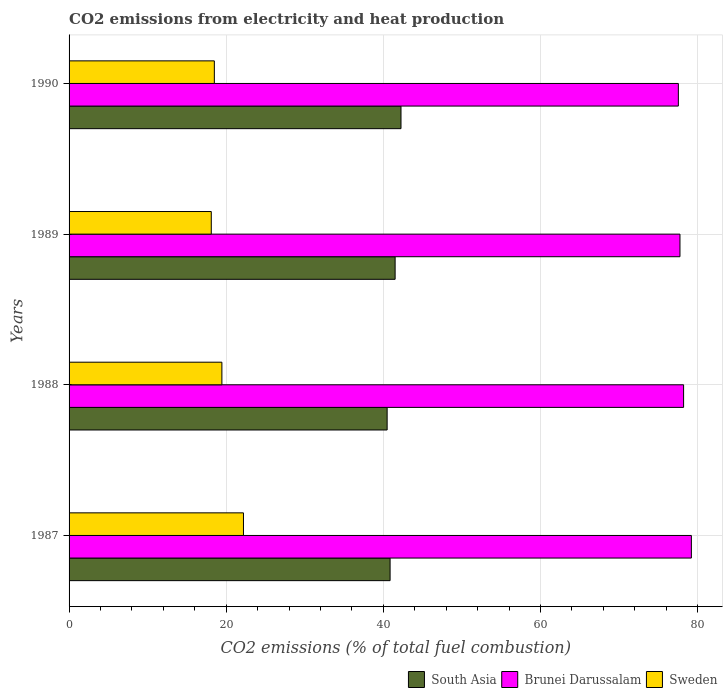How many bars are there on the 3rd tick from the top?
Make the answer very short. 3. What is the amount of CO2 emitted in Brunei Darussalam in 1989?
Your answer should be very brief. 77.74. Across all years, what is the maximum amount of CO2 emitted in Sweden?
Provide a short and direct response. 22.19. Across all years, what is the minimum amount of CO2 emitted in Brunei Darussalam?
Ensure brevity in your answer.  77.54. In which year was the amount of CO2 emitted in South Asia maximum?
Keep it short and to the point. 1990. In which year was the amount of CO2 emitted in Brunei Darussalam minimum?
Provide a succinct answer. 1990. What is the total amount of CO2 emitted in Brunei Darussalam in the graph?
Offer a terse response. 312.68. What is the difference between the amount of CO2 emitted in Brunei Darussalam in 1987 and that in 1990?
Give a very brief answer. 1.66. What is the difference between the amount of CO2 emitted in Sweden in 1988 and the amount of CO2 emitted in Brunei Darussalam in 1989?
Make the answer very short. -58.29. What is the average amount of CO2 emitted in South Asia per year?
Offer a very short reply. 41.27. In the year 1989, what is the difference between the amount of CO2 emitted in South Asia and amount of CO2 emitted in Sweden?
Provide a short and direct response. 23.39. What is the ratio of the amount of CO2 emitted in Brunei Darussalam in 1987 to that in 1989?
Your response must be concise. 1.02. What is the difference between the highest and the second highest amount of CO2 emitted in Sweden?
Provide a succinct answer. 2.75. What is the difference between the highest and the lowest amount of CO2 emitted in Brunei Darussalam?
Provide a short and direct response. 1.66. In how many years, is the amount of CO2 emitted in Brunei Darussalam greater than the average amount of CO2 emitted in Brunei Darussalam taken over all years?
Your answer should be compact. 2. What does the 3rd bar from the bottom in 1987 represents?
Your answer should be very brief. Sweden. What is the title of the graph?
Provide a succinct answer. CO2 emissions from electricity and heat production. What is the label or title of the X-axis?
Offer a terse response. CO2 emissions (% of total fuel combustion). What is the label or title of the Y-axis?
Keep it short and to the point. Years. What is the CO2 emissions (% of total fuel combustion) in South Asia in 1987?
Provide a succinct answer. 40.85. What is the CO2 emissions (% of total fuel combustion) in Brunei Darussalam in 1987?
Make the answer very short. 79.19. What is the CO2 emissions (% of total fuel combustion) in Sweden in 1987?
Your answer should be very brief. 22.19. What is the CO2 emissions (% of total fuel combustion) of South Asia in 1988?
Your response must be concise. 40.48. What is the CO2 emissions (% of total fuel combustion) of Brunei Darussalam in 1988?
Keep it short and to the point. 78.21. What is the CO2 emissions (% of total fuel combustion) in Sweden in 1988?
Provide a succinct answer. 19.45. What is the CO2 emissions (% of total fuel combustion) in South Asia in 1989?
Give a very brief answer. 41.49. What is the CO2 emissions (% of total fuel combustion) of Brunei Darussalam in 1989?
Ensure brevity in your answer.  77.74. What is the CO2 emissions (% of total fuel combustion) of Sweden in 1989?
Your answer should be compact. 18.1. What is the CO2 emissions (% of total fuel combustion) of South Asia in 1990?
Give a very brief answer. 42.24. What is the CO2 emissions (% of total fuel combustion) in Brunei Darussalam in 1990?
Your response must be concise. 77.54. What is the CO2 emissions (% of total fuel combustion) of Sweden in 1990?
Give a very brief answer. 18.49. Across all years, what is the maximum CO2 emissions (% of total fuel combustion) of South Asia?
Your answer should be compact. 42.24. Across all years, what is the maximum CO2 emissions (% of total fuel combustion) of Brunei Darussalam?
Make the answer very short. 79.19. Across all years, what is the maximum CO2 emissions (% of total fuel combustion) in Sweden?
Keep it short and to the point. 22.19. Across all years, what is the minimum CO2 emissions (% of total fuel combustion) in South Asia?
Your answer should be compact. 40.48. Across all years, what is the minimum CO2 emissions (% of total fuel combustion) in Brunei Darussalam?
Your response must be concise. 77.54. Across all years, what is the minimum CO2 emissions (% of total fuel combustion) in Sweden?
Your response must be concise. 18.1. What is the total CO2 emissions (% of total fuel combustion) in South Asia in the graph?
Your answer should be very brief. 165.06. What is the total CO2 emissions (% of total fuel combustion) in Brunei Darussalam in the graph?
Your answer should be very brief. 312.68. What is the total CO2 emissions (% of total fuel combustion) of Sweden in the graph?
Give a very brief answer. 78.23. What is the difference between the CO2 emissions (% of total fuel combustion) of South Asia in 1987 and that in 1988?
Your response must be concise. 0.38. What is the difference between the CO2 emissions (% of total fuel combustion) of Sweden in 1987 and that in 1988?
Provide a short and direct response. 2.75. What is the difference between the CO2 emissions (% of total fuel combustion) in South Asia in 1987 and that in 1989?
Give a very brief answer. -0.64. What is the difference between the CO2 emissions (% of total fuel combustion) of Brunei Darussalam in 1987 and that in 1989?
Make the answer very short. 1.45. What is the difference between the CO2 emissions (% of total fuel combustion) in Sweden in 1987 and that in 1989?
Keep it short and to the point. 4.1. What is the difference between the CO2 emissions (% of total fuel combustion) of South Asia in 1987 and that in 1990?
Give a very brief answer. -1.39. What is the difference between the CO2 emissions (% of total fuel combustion) in Brunei Darussalam in 1987 and that in 1990?
Make the answer very short. 1.66. What is the difference between the CO2 emissions (% of total fuel combustion) of Sweden in 1987 and that in 1990?
Provide a short and direct response. 3.71. What is the difference between the CO2 emissions (% of total fuel combustion) of South Asia in 1988 and that in 1989?
Your response must be concise. -1.02. What is the difference between the CO2 emissions (% of total fuel combustion) in Brunei Darussalam in 1988 and that in 1989?
Provide a short and direct response. 0.46. What is the difference between the CO2 emissions (% of total fuel combustion) in Sweden in 1988 and that in 1989?
Ensure brevity in your answer.  1.35. What is the difference between the CO2 emissions (% of total fuel combustion) of South Asia in 1988 and that in 1990?
Your answer should be compact. -1.76. What is the difference between the CO2 emissions (% of total fuel combustion) of Brunei Darussalam in 1988 and that in 1990?
Your answer should be very brief. 0.67. What is the difference between the CO2 emissions (% of total fuel combustion) in Sweden in 1988 and that in 1990?
Ensure brevity in your answer.  0.96. What is the difference between the CO2 emissions (% of total fuel combustion) in South Asia in 1989 and that in 1990?
Offer a terse response. -0.75. What is the difference between the CO2 emissions (% of total fuel combustion) of Brunei Darussalam in 1989 and that in 1990?
Offer a very short reply. 0.2. What is the difference between the CO2 emissions (% of total fuel combustion) in Sweden in 1989 and that in 1990?
Your answer should be very brief. -0.39. What is the difference between the CO2 emissions (% of total fuel combustion) of South Asia in 1987 and the CO2 emissions (% of total fuel combustion) of Brunei Darussalam in 1988?
Your answer should be compact. -37.35. What is the difference between the CO2 emissions (% of total fuel combustion) in South Asia in 1987 and the CO2 emissions (% of total fuel combustion) in Sweden in 1988?
Give a very brief answer. 21.4. What is the difference between the CO2 emissions (% of total fuel combustion) of Brunei Darussalam in 1987 and the CO2 emissions (% of total fuel combustion) of Sweden in 1988?
Offer a terse response. 59.75. What is the difference between the CO2 emissions (% of total fuel combustion) of South Asia in 1987 and the CO2 emissions (% of total fuel combustion) of Brunei Darussalam in 1989?
Offer a terse response. -36.89. What is the difference between the CO2 emissions (% of total fuel combustion) of South Asia in 1987 and the CO2 emissions (% of total fuel combustion) of Sweden in 1989?
Your answer should be very brief. 22.75. What is the difference between the CO2 emissions (% of total fuel combustion) of Brunei Darussalam in 1987 and the CO2 emissions (% of total fuel combustion) of Sweden in 1989?
Your answer should be very brief. 61.1. What is the difference between the CO2 emissions (% of total fuel combustion) in South Asia in 1987 and the CO2 emissions (% of total fuel combustion) in Brunei Darussalam in 1990?
Ensure brevity in your answer.  -36.69. What is the difference between the CO2 emissions (% of total fuel combustion) in South Asia in 1987 and the CO2 emissions (% of total fuel combustion) in Sweden in 1990?
Offer a very short reply. 22.36. What is the difference between the CO2 emissions (% of total fuel combustion) of Brunei Darussalam in 1987 and the CO2 emissions (% of total fuel combustion) of Sweden in 1990?
Offer a terse response. 60.71. What is the difference between the CO2 emissions (% of total fuel combustion) in South Asia in 1988 and the CO2 emissions (% of total fuel combustion) in Brunei Darussalam in 1989?
Provide a succinct answer. -37.27. What is the difference between the CO2 emissions (% of total fuel combustion) in South Asia in 1988 and the CO2 emissions (% of total fuel combustion) in Sweden in 1989?
Make the answer very short. 22.38. What is the difference between the CO2 emissions (% of total fuel combustion) in Brunei Darussalam in 1988 and the CO2 emissions (% of total fuel combustion) in Sweden in 1989?
Provide a short and direct response. 60.11. What is the difference between the CO2 emissions (% of total fuel combustion) in South Asia in 1988 and the CO2 emissions (% of total fuel combustion) in Brunei Darussalam in 1990?
Make the answer very short. -37.06. What is the difference between the CO2 emissions (% of total fuel combustion) of South Asia in 1988 and the CO2 emissions (% of total fuel combustion) of Sweden in 1990?
Offer a terse response. 21.99. What is the difference between the CO2 emissions (% of total fuel combustion) of Brunei Darussalam in 1988 and the CO2 emissions (% of total fuel combustion) of Sweden in 1990?
Give a very brief answer. 59.72. What is the difference between the CO2 emissions (% of total fuel combustion) of South Asia in 1989 and the CO2 emissions (% of total fuel combustion) of Brunei Darussalam in 1990?
Offer a terse response. -36.05. What is the difference between the CO2 emissions (% of total fuel combustion) in South Asia in 1989 and the CO2 emissions (% of total fuel combustion) in Sweden in 1990?
Ensure brevity in your answer.  23. What is the difference between the CO2 emissions (% of total fuel combustion) of Brunei Darussalam in 1989 and the CO2 emissions (% of total fuel combustion) of Sweden in 1990?
Offer a very short reply. 59.25. What is the average CO2 emissions (% of total fuel combustion) in South Asia per year?
Keep it short and to the point. 41.27. What is the average CO2 emissions (% of total fuel combustion) of Brunei Darussalam per year?
Keep it short and to the point. 78.17. What is the average CO2 emissions (% of total fuel combustion) in Sweden per year?
Provide a succinct answer. 19.56. In the year 1987, what is the difference between the CO2 emissions (% of total fuel combustion) in South Asia and CO2 emissions (% of total fuel combustion) in Brunei Darussalam?
Give a very brief answer. -38.34. In the year 1987, what is the difference between the CO2 emissions (% of total fuel combustion) of South Asia and CO2 emissions (% of total fuel combustion) of Sweden?
Your answer should be very brief. 18.66. In the year 1987, what is the difference between the CO2 emissions (% of total fuel combustion) in Brunei Darussalam and CO2 emissions (% of total fuel combustion) in Sweden?
Your answer should be compact. 57. In the year 1988, what is the difference between the CO2 emissions (% of total fuel combustion) of South Asia and CO2 emissions (% of total fuel combustion) of Brunei Darussalam?
Offer a terse response. -37.73. In the year 1988, what is the difference between the CO2 emissions (% of total fuel combustion) of South Asia and CO2 emissions (% of total fuel combustion) of Sweden?
Provide a succinct answer. 21.03. In the year 1988, what is the difference between the CO2 emissions (% of total fuel combustion) of Brunei Darussalam and CO2 emissions (% of total fuel combustion) of Sweden?
Your answer should be very brief. 58.76. In the year 1989, what is the difference between the CO2 emissions (% of total fuel combustion) of South Asia and CO2 emissions (% of total fuel combustion) of Brunei Darussalam?
Make the answer very short. -36.25. In the year 1989, what is the difference between the CO2 emissions (% of total fuel combustion) in South Asia and CO2 emissions (% of total fuel combustion) in Sweden?
Provide a succinct answer. 23.39. In the year 1989, what is the difference between the CO2 emissions (% of total fuel combustion) of Brunei Darussalam and CO2 emissions (% of total fuel combustion) of Sweden?
Make the answer very short. 59.64. In the year 1990, what is the difference between the CO2 emissions (% of total fuel combustion) of South Asia and CO2 emissions (% of total fuel combustion) of Brunei Darussalam?
Your answer should be very brief. -35.3. In the year 1990, what is the difference between the CO2 emissions (% of total fuel combustion) of South Asia and CO2 emissions (% of total fuel combustion) of Sweden?
Your answer should be very brief. 23.75. In the year 1990, what is the difference between the CO2 emissions (% of total fuel combustion) in Brunei Darussalam and CO2 emissions (% of total fuel combustion) in Sweden?
Ensure brevity in your answer.  59.05. What is the ratio of the CO2 emissions (% of total fuel combustion) of South Asia in 1987 to that in 1988?
Make the answer very short. 1.01. What is the ratio of the CO2 emissions (% of total fuel combustion) in Brunei Darussalam in 1987 to that in 1988?
Ensure brevity in your answer.  1.01. What is the ratio of the CO2 emissions (% of total fuel combustion) in Sweden in 1987 to that in 1988?
Make the answer very short. 1.14. What is the ratio of the CO2 emissions (% of total fuel combustion) in South Asia in 1987 to that in 1989?
Offer a very short reply. 0.98. What is the ratio of the CO2 emissions (% of total fuel combustion) of Brunei Darussalam in 1987 to that in 1989?
Offer a very short reply. 1.02. What is the ratio of the CO2 emissions (% of total fuel combustion) of Sweden in 1987 to that in 1989?
Your answer should be very brief. 1.23. What is the ratio of the CO2 emissions (% of total fuel combustion) in South Asia in 1987 to that in 1990?
Your response must be concise. 0.97. What is the ratio of the CO2 emissions (% of total fuel combustion) of Brunei Darussalam in 1987 to that in 1990?
Make the answer very short. 1.02. What is the ratio of the CO2 emissions (% of total fuel combustion) of Sweden in 1987 to that in 1990?
Offer a very short reply. 1.2. What is the ratio of the CO2 emissions (% of total fuel combustion) of South Asia in 1988 to that in 1989?
Provide a succinct answer. 0.98. What is the ratio of the CO2 emissions (% of total fuel combustion) of Sweden in 1988 to that in 1989?
Your answer should be compact. 1.07. What is the ratio of the CO2 emissions (% of total fuel combustion) of South Asia in 1988 to that in 1990?
Offer a very short reply. 0.96. What is the ratio of the CO2 emissions (% of total fuel combustion) in Brunei Darussalam in 1988 to that in 1990?
Your answer should be very brief. 1.01. What is the ratio of the CO2 emissions (% of total fuel combustion) in Sweden in 1988 to that in 1990?
Offer a very short reply. 1.05. What is the ratio of the CO2 emissions (% of total fuel combustion) in South Asia in 1989 to that in 1990?
Make the answer very short. 0.98. What is the ratio of the CO2 emissions (% of total fuel combustion) in Sweden in 1989 to that in 1990?
Offer a terse response. 0.98. What is the difference between the highest and the second highest CO2 emissions (% of total fuel combustion) in South Asia?
Offer a terse response. 0.75. What is the difference between the highest and the second highest CO2 emissions (% of total fuel combustion) of Brunei Darussalam?
Your answer should be very brief. 0.99. What is the difference between the highest and the second highest CO2 emissions (% of total fuel combustion) in Sweden?
Give a very brief answer. 2.75. What is the difference between the highest and the lowest CO2 emissions (% of total fuel combustion) of South Asia?
Provide a succinct answer. 1.76. What is the difference between the highest and the lowest CO2 emissions (% of total fuel combustion) of Brunei Darussalam?
Offer a terse response. 1.66. What is the difference between the highest and the lowest CO2 emissions (% of total fuel combustion) of Sweden?
Keep it short and to the point. 4.1. 